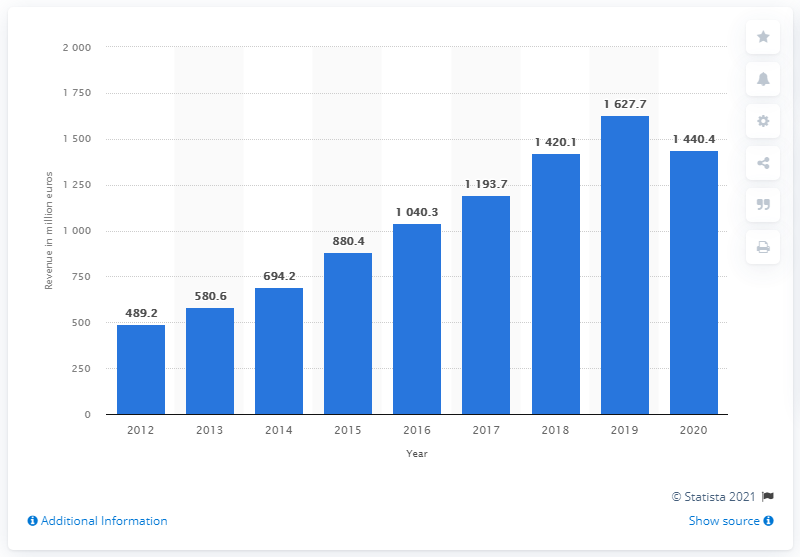List a handful of essential elements in this visual. In the most recent period, Moncler's global revenue was 1440.4. 